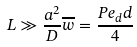Convert formula to latex. <formula><loc_0><loc_0><loc_500><loc_500>L \gg \frac { a ^ { 2 } } { D } \overline { w } = \frac { P e _ { d } d } { 4 }</formula> 